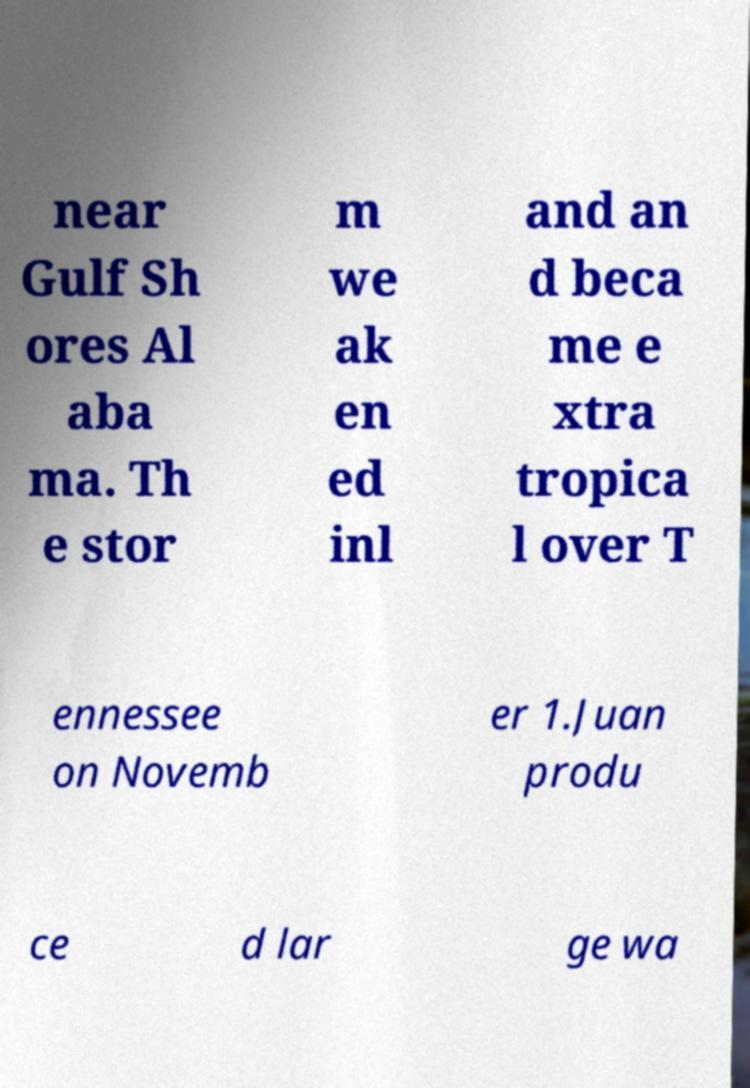Can you read and provide the text displayed in the image?This photo seems to have some interesting text. Can you extract and type it out for me? near Gulf Sh ores Al aba ma. Th e stor m we ak en ed inl and an d beca me e xtra tropica l over T ennessee on Novemb er 1.Juan produ ce d lar ge wa 